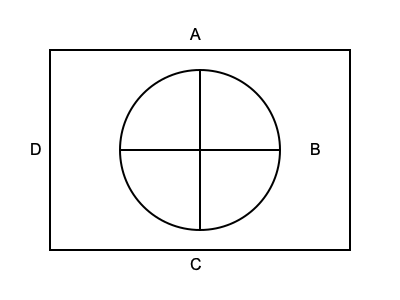In the sacred representation above, what is the symbolic meaning of the circle within the square, according to traditional theological interpretations? 1. The image presents a square containing a circle, with a cross formed by intersecting lines within the circle.

2. In traditional theological interpretations, geometric shapes often carry deep symbolic meanings:

   a. The square represents the earthly realm, with its four cardinal directions and four elements.
   
   b. The circle symbolizes the divine or heavenly realm, representing eternity, perfection, and unity.
   
   c. The cross within the circle signifies the intersection of the divine and human realms.

3. The circle within the square, therefore, represents the presence of the divine within the earthly world.

4. This interpretation is based on long-standing theological traditions and scriptural exegesis, not on archaeological findings.

5. The symbolic meaning emphasizes the immanence of the divine in the material world, a concept central to many religious teachings.

6. This representation reinforces the idea of sacred space, where the earthly (square) encompasses and protects the divine (circle).
Answer: Divine presence within the earthly realm 